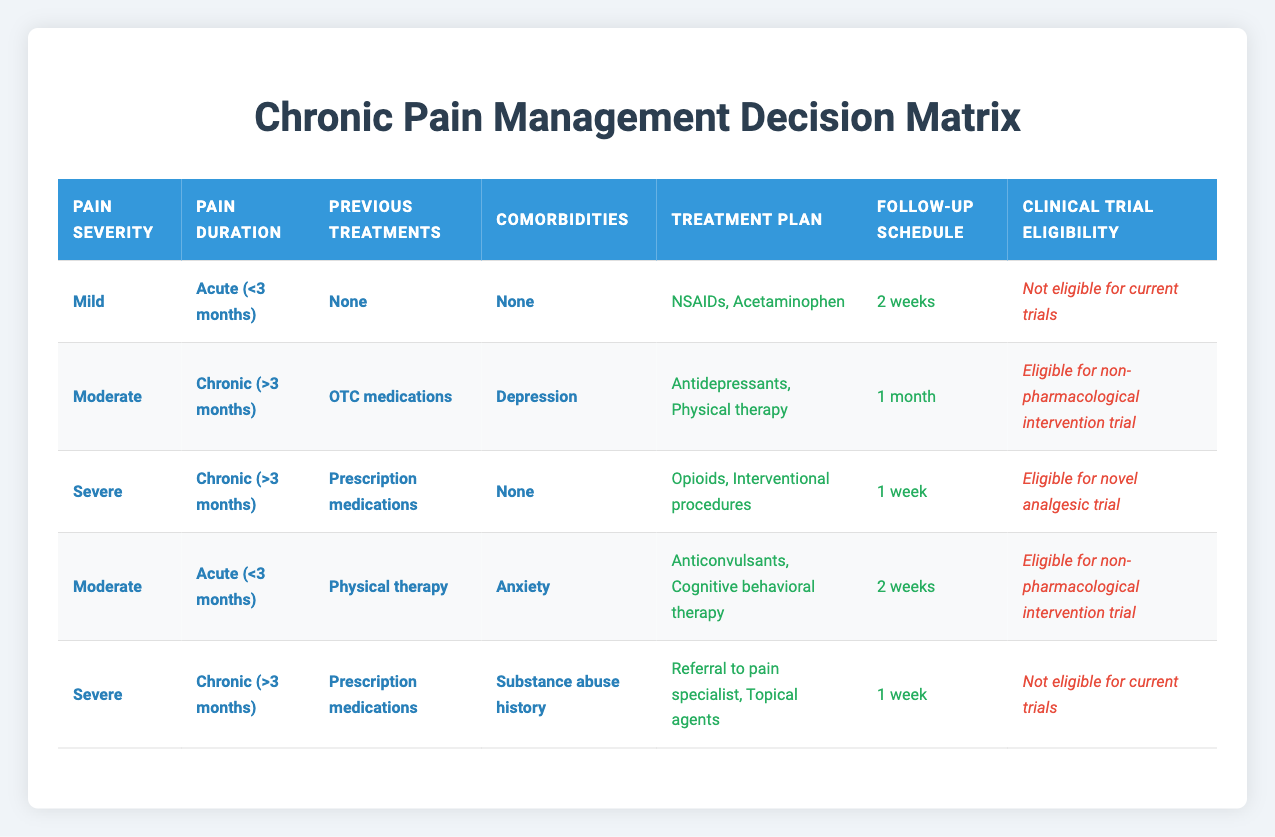What are the treatment options for patients with mild pain who have not received any previous treatment? According to the table, for patients with mild pain severity, an acute duration of less than three months, no previous treatment, and no comorbidities, the treatment options include NSAIDs and Acetaminophen.
Answer: NSAIDs, Acetaminophen For patients who have chronic pain and have previously used OTC medications, what treatment plan is suggested? The table indicates that for patients with chronic pain, moderate severity, who have previously been treated with OTC medications and have comorbidities like depression, the suggested treatment plan includes Antidepressants and Physical therapy.
Answer: Antidepressants, Physical therapy Is there a specific follow-up schedule for patients who are eligible for a novel analgesic trial? Looking at the table, patients with severe chronic pain who have used prescription medications and have no comorbidities are eligible for the novel analgesic trial, and their follow-up schedule is set for 1 week.
Answer: 1 week How many total distinct clinical trial eligibility categories are listed in the table? The table lists three distinct categories for clinical trial eligibility: "Eligible for novel analgesic trial," "Eligible for non-pharmacological intervention trial," and "Not eligible for current trials." Therefore, the total number of distinct categories is three.
Answer: 3 Can a patient with severe chronic pain and a substance abuse history participate in any clinical trials? The table indicates that for patients with severe chronic pain, a history of prescription medication use, and a substance abuse history, they are not eligible for any current trials. Consequently, the answer is no.
Answer: No Are patients with mild pain always ineligible for clinical trials? According to the data in the table, patients with mild pain severity and specific conditions (like those with no previous treatments and no comorbidities) are listed as "Not eligible for current trials." However, there may be other scenarios not covered in the table. Hence, the statement cannot be universally true.
Answer: No What is the follow-up period for patients undergoing cognitive behavioral therapy? From the observations in the table, patients with moderate acute pain who have previously undergone physical therapy and have anxiety are recommended to follow up in 2 weeks while receiving cognitive behavioral therapy.
Answer: 2 weeks In what scenarios is physical therapy recommended in the treatment plan? Reviewing the table, physical therapy is recommended for patients with chronic pain of moderate severity and previous use of OTC medications and comorbidities of depression, as well as for those with moderate acute pain, previous physical therapy, and anxiety. Hence, both scenarios involve moderate pain severity and are tied to specific previous treatments and comorbidities.
Answer: Two scenarios: moderate chronic pain with depression, moderate acute pain with anxiety 